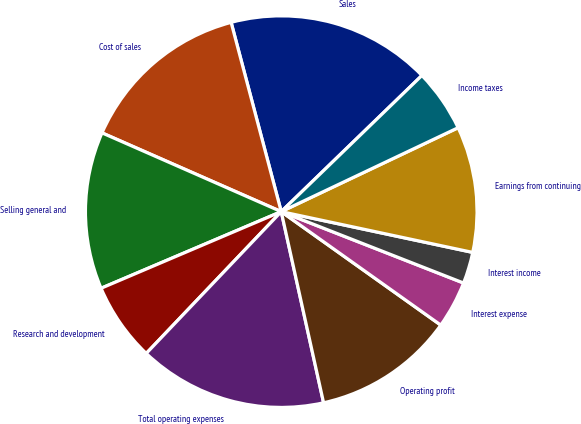<chart> <loc_0><loc_0><loc_500><loc_500><pie_chart><fcel>Sales<fcel>Cost of sales<fcel>Selling general and<fcel>Research and development<fcel>Total operating expenses<fcel>Operating profit<fcel>Interest expense<fcel>Interest income<fcel>Earnings from continuing<fcel>Income taxes<nl><fcel>16.88%<fcel>14.29%<fcel>12.99%<fcel>6.49%<fcel>15.58%<fcel>11.69%<fcel>3.9%<fcel>2.6%<fcel>10.39%<fcel>5.19%<nl></chart> 